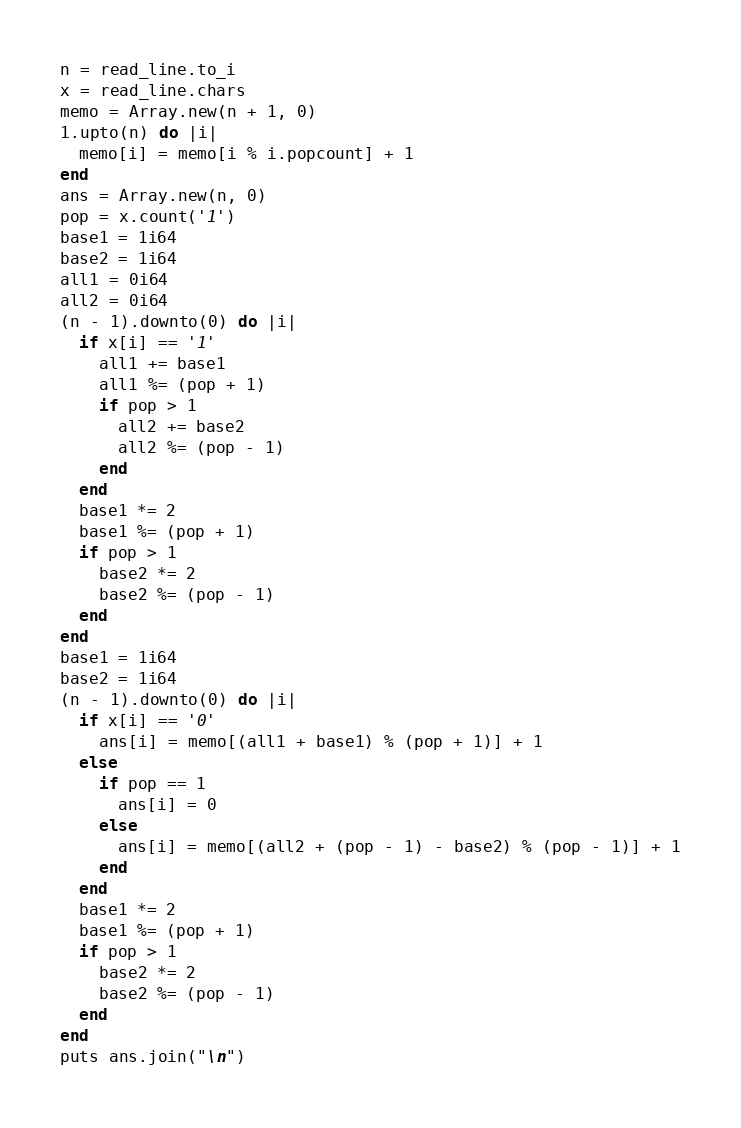Convert code to text. <code><loc_0><loc_0><loc_500><loc_500><_Crystal_>n = read_line.to_i
x = read_line.chars
memo = Array.new(n + 1, 0)
1.upto(n) do |i|
  memo[i] = memo[i % i.popcount] + 1
end
ans = Array.new(n, 0)
pop = x.count('1')
base1 = 1i64
base2 = 1i64
all1 = 0i64
all2 = 0i64
(n - 1).downto(0) do |i|
  if x[i] == '1'
    all1 += base1
    all1 %= (pop + 1)
    if pop > 1
      all2 += base2
      all2 %= (pop - 1)
    end
  end
  base1 *= 2
  base1 %= (pop + 1)
  if pop > 1
    base2 *= 2
    base2 %= (pop - 1)
  end
end
base1 = 1i64
base2 = 1i64
(n - 1).downto(0) do |i|
  if x[i] == '0'
    ans[i] = memo[(all1 + base1) % (pop + 1)] + 1
  else
    if pop == 1
      ans[i] = 0
    else
      ans[i] = memo[(all2 + (pop - 1) - base2) % (pop - 1)] + 1
    end
  end
  base1 *= 2
  base1 %= (pop + 1)
  if pop > 1
    base2 *= 2
    base2 %= (pop - 1)
  end
end
puts ans.join("\n")
</code> 